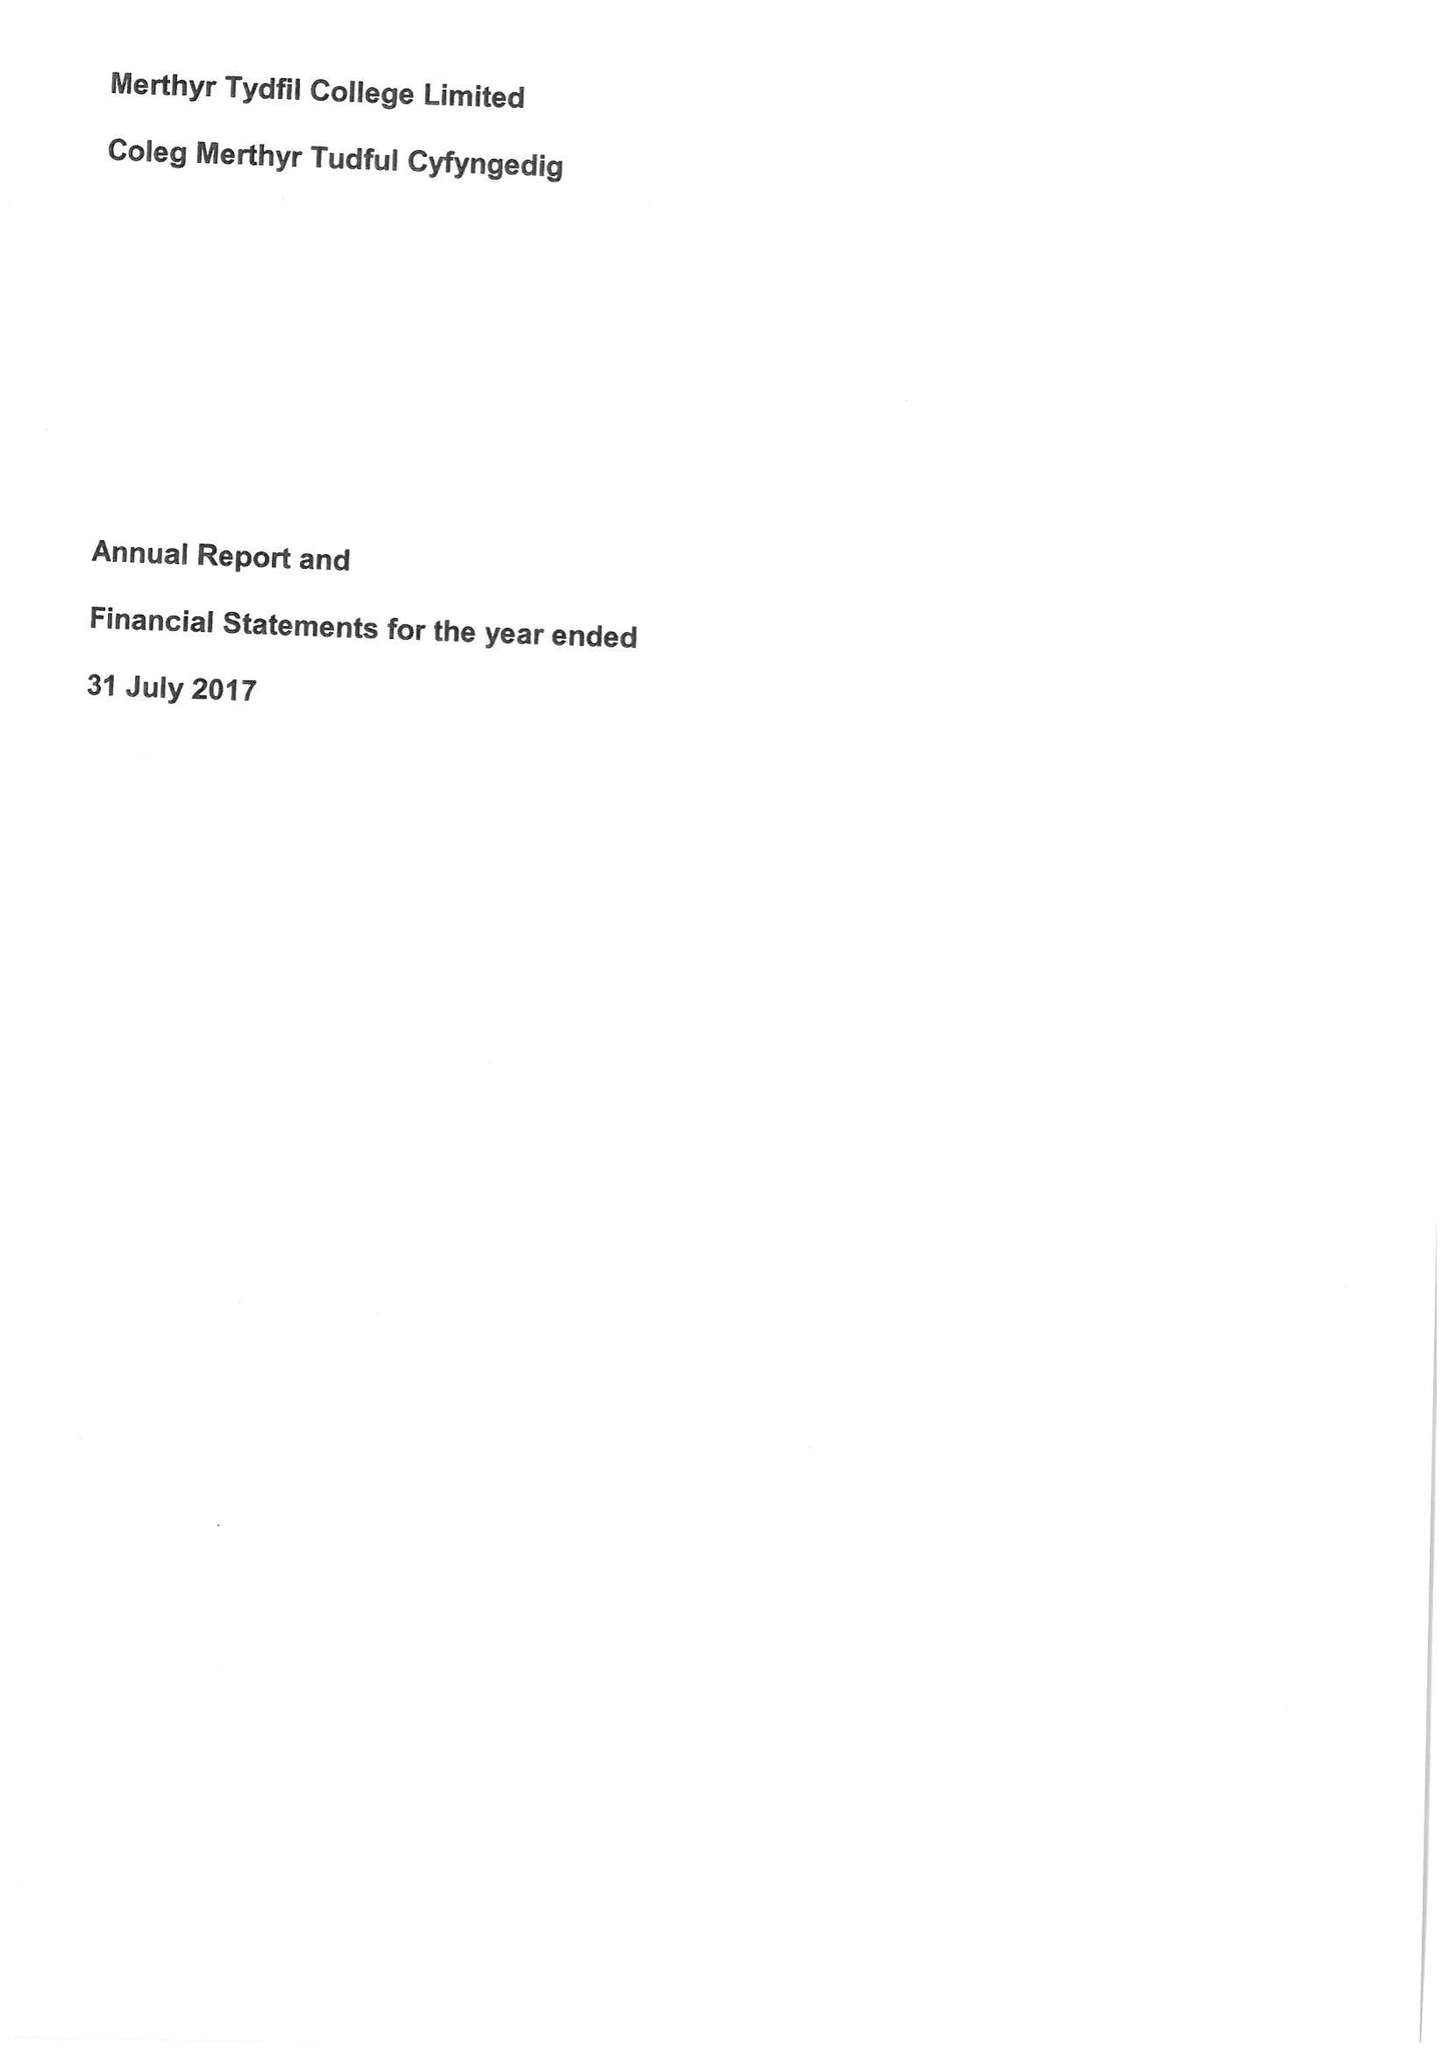What is the value for the report_date?
Answer the question using a single word or phrase. 2017-07-31 